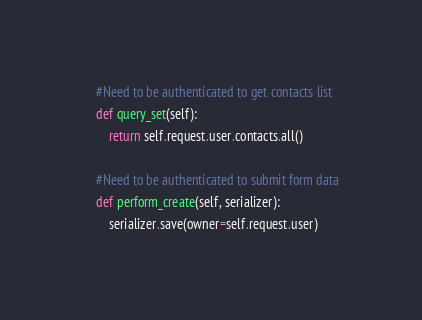Convert code to text. <code><loc_0><loc_0><loc_500><loc_500><_Python_>    #Need to be authenticated to get contacts list
    def query_set(self):
        return self.request.user.contacts.all()
    
    #Need to be authenticated to submit form data
    def perform_create(self, serializer):
        serializer.save(owner=self.request.user)</code> 